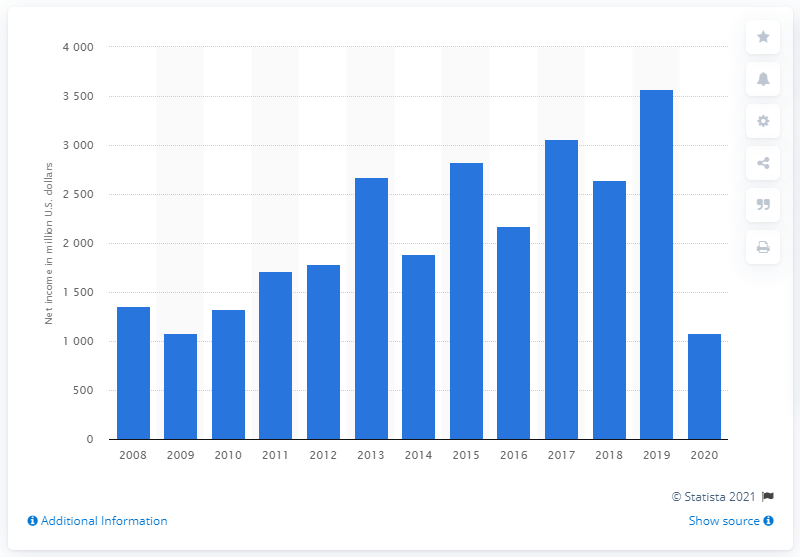Point out several critical features in this image. In 2019, Duke Energy reported a net income of $3,571 million. 